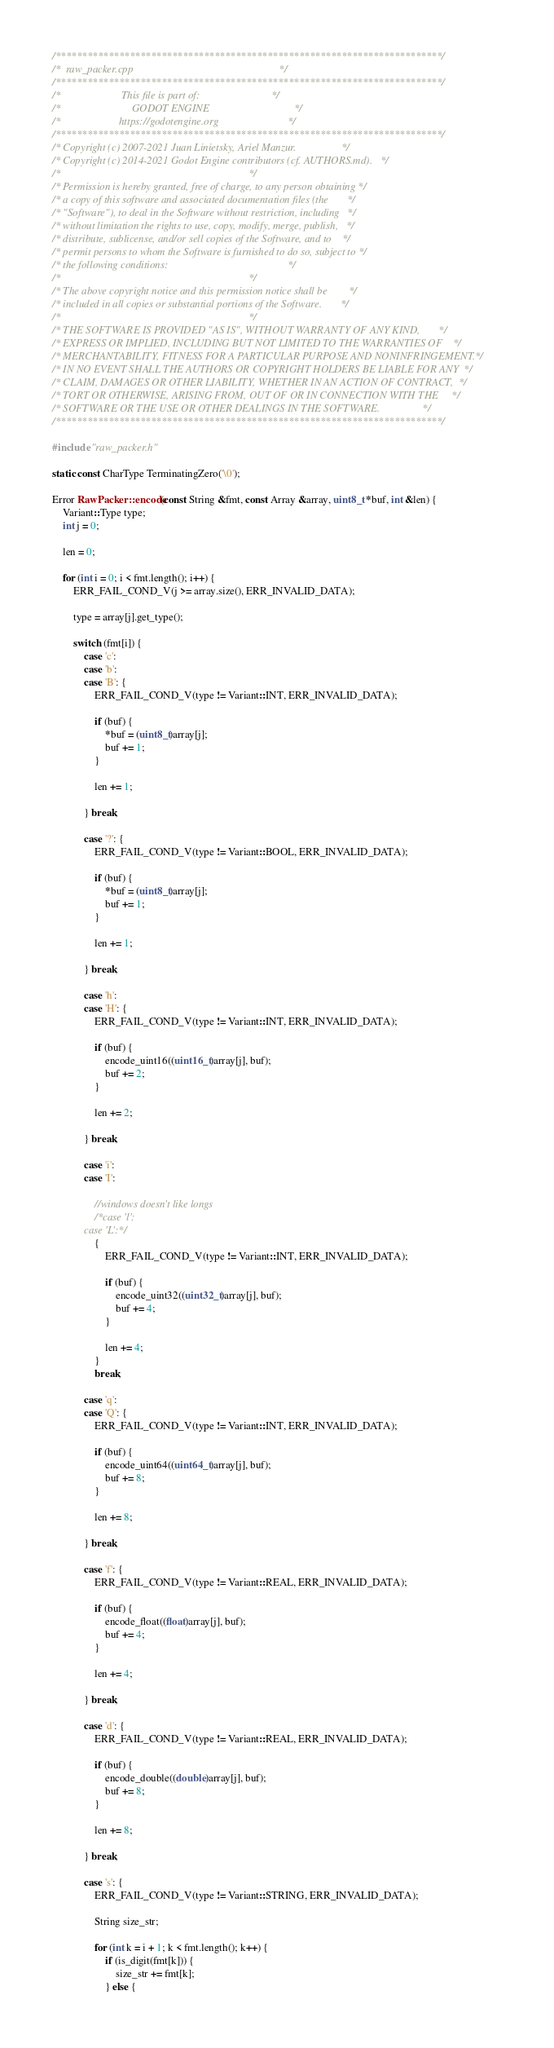<code> <loc_0><loc_0><loc_500><loc_500><_C++_>/*************************************************************************/
/*  raw_packer.cpp                                                       */
/*************************************************************************/
/*                       This file is part of:                           */
/*                           GODOT ENGINE                                */
/*                      https://godotengine.org                          */
/*************************************************************************/
/* Copyright (c) 2007-2021 Juan Linietsky, Ariel Manzur.                 */
/* Copyright (c) 2014-2021 Godot Engine contributors (cf. AUTHORS.md).   */
/*                                                                       */
/* Permission is hereby granted, free of charge, to any person obtaining */
/* a copy of this software and associated documentation files (the       */
/* "Software"), to deal in the Software without restriction, including   */
/* without limitation the rights to use, copy, modify, merge, publish,   */
/* distribute, sublicense, and/or sell copies of the Software, and to    */
/* permit persons to whom the Software is furnished to do so, subject to */
/* the following conditions:                                             */
/*                                                                       */
/* The above copyright notice and this permission notice shall be        */
/* included in all copies or substantial portions of the Software.       */
/*                                                                       */
/* THE SOFTWARE IS PROVIDED "AS IS", WITHOUT WARRANTY OF ANY KIND,       */
/* EXPRESS OR IMPLIED, INCLUDING BUT NOT LIMITED TO THE WARRANTIES OF    */
/* MERCHANTABILITY, FITNESS FOR A PARTICULAR PURPOSE AND NONINFRINGEMENT.*/
/* IN NO EVENT SHALL THE AUTHORS OR COPYRIGHT HOLDERS BE LIABLE FOR ANY  */
/* CLAIM, DAMAGES OR OTHER LIABILITY, WHETHER IN AN ACTION OF CONTRACT,  */
/* TORT OR OTHERWISE, ARISING FROM, OUT OF OR IN CONNECTION WITH THE     */
/* SOFTWARE OR THE USE OR OTHER DEALINGS IN THE SOFTWARE.                */
/*************************************************************************/

#include "raw_packer.h"

static const CharType TerminatingZero('\0');

Error RawPacker::encode(const String &fmt, const Array &array, uint8_t *buf, int &len) {
	Variant::Type type;
	int j = 0;

	len = 0;

	for (int i = 0; i < fmt.length(); i++) {
		ERR_FAIL_COND_V(j >= array.size(), ERR_INVALID_DATA);

		type = array[j].get_type();

		switch (fmt[i]) {
			case 'c':
			case 'b':
			case 'B': {
				ERR_FAIL_COND_V(type != Variant::INT, ERR_INVALID_DATA);

				if (buf) {
					*buf = (uint8_t)array[j];
					buf += 1;
				}

				len += 1;

			} break;

			case '?': {
				ERR_FAIL_COND_V(type != Variant::BOOL, ERR_INVALID_DATA);

				if (buf) {
					*buf = (uint8_t)array[j];
					buf += 1;
				}

				len += 1;

			} break;

			case 'h':
			case 'H': {
				ERR_FAIL_COND_V(type != Variant::INT, ERR_INVALID_DATA);

				if (buf) {
					encode_uint16((uint16_t)array[j], buf);
					buf += 2;
				}

				len += 2;

			} break;

			case 'i':
			case 'I':

				//windows doesn't like longs
				/*case 'l':
			case 'L':*/
				{
					ERR_FAIL_COND_V(type != Variant::INT, ERR_INVALID_DATA);

					if (buf) {
						encode_uint32((uint32_t)array[j], buf);
						buf += 4;
					}

					len += 4;
				}
				break;

			case 'q':
			case 'Q': {
				ERR_FAIL_COND_V(type != Variant::INT, ERR_INVALID_DATA);

				if (buf) {
					encode_uint64((uint64_t)array[j], buf);
					buf += 8;
				}

				len += 8;

			} break;

			case 'f': {
				ERR_FAIL_COND_V(type != Variant::REAL, ERR_INVALID_DATA);

				if (buf) {
					encode_float((float)array[j], buf);
					buf += 4;
				}

				len += 4;

			} break;

			case 'd': {
				ERR_FAIL_COND_V(type != Variant::REAL, ERR_INVALID_DATA);

				if (buf) {
					encode_double((double)array[j], buf);
					buf += 8;
				}

				len += 8;

			} break;

			case 's': {
				ERR_FAIL_COND_V(type != Variant::STRING, ERR_INVALID_DATA);

				String size_str;

				for (int k = i + 1; k < fmt.length(); k++) {
					if (is_digit(fmt[k])) {
						size_str += fmt[k];
					} else {</code> 